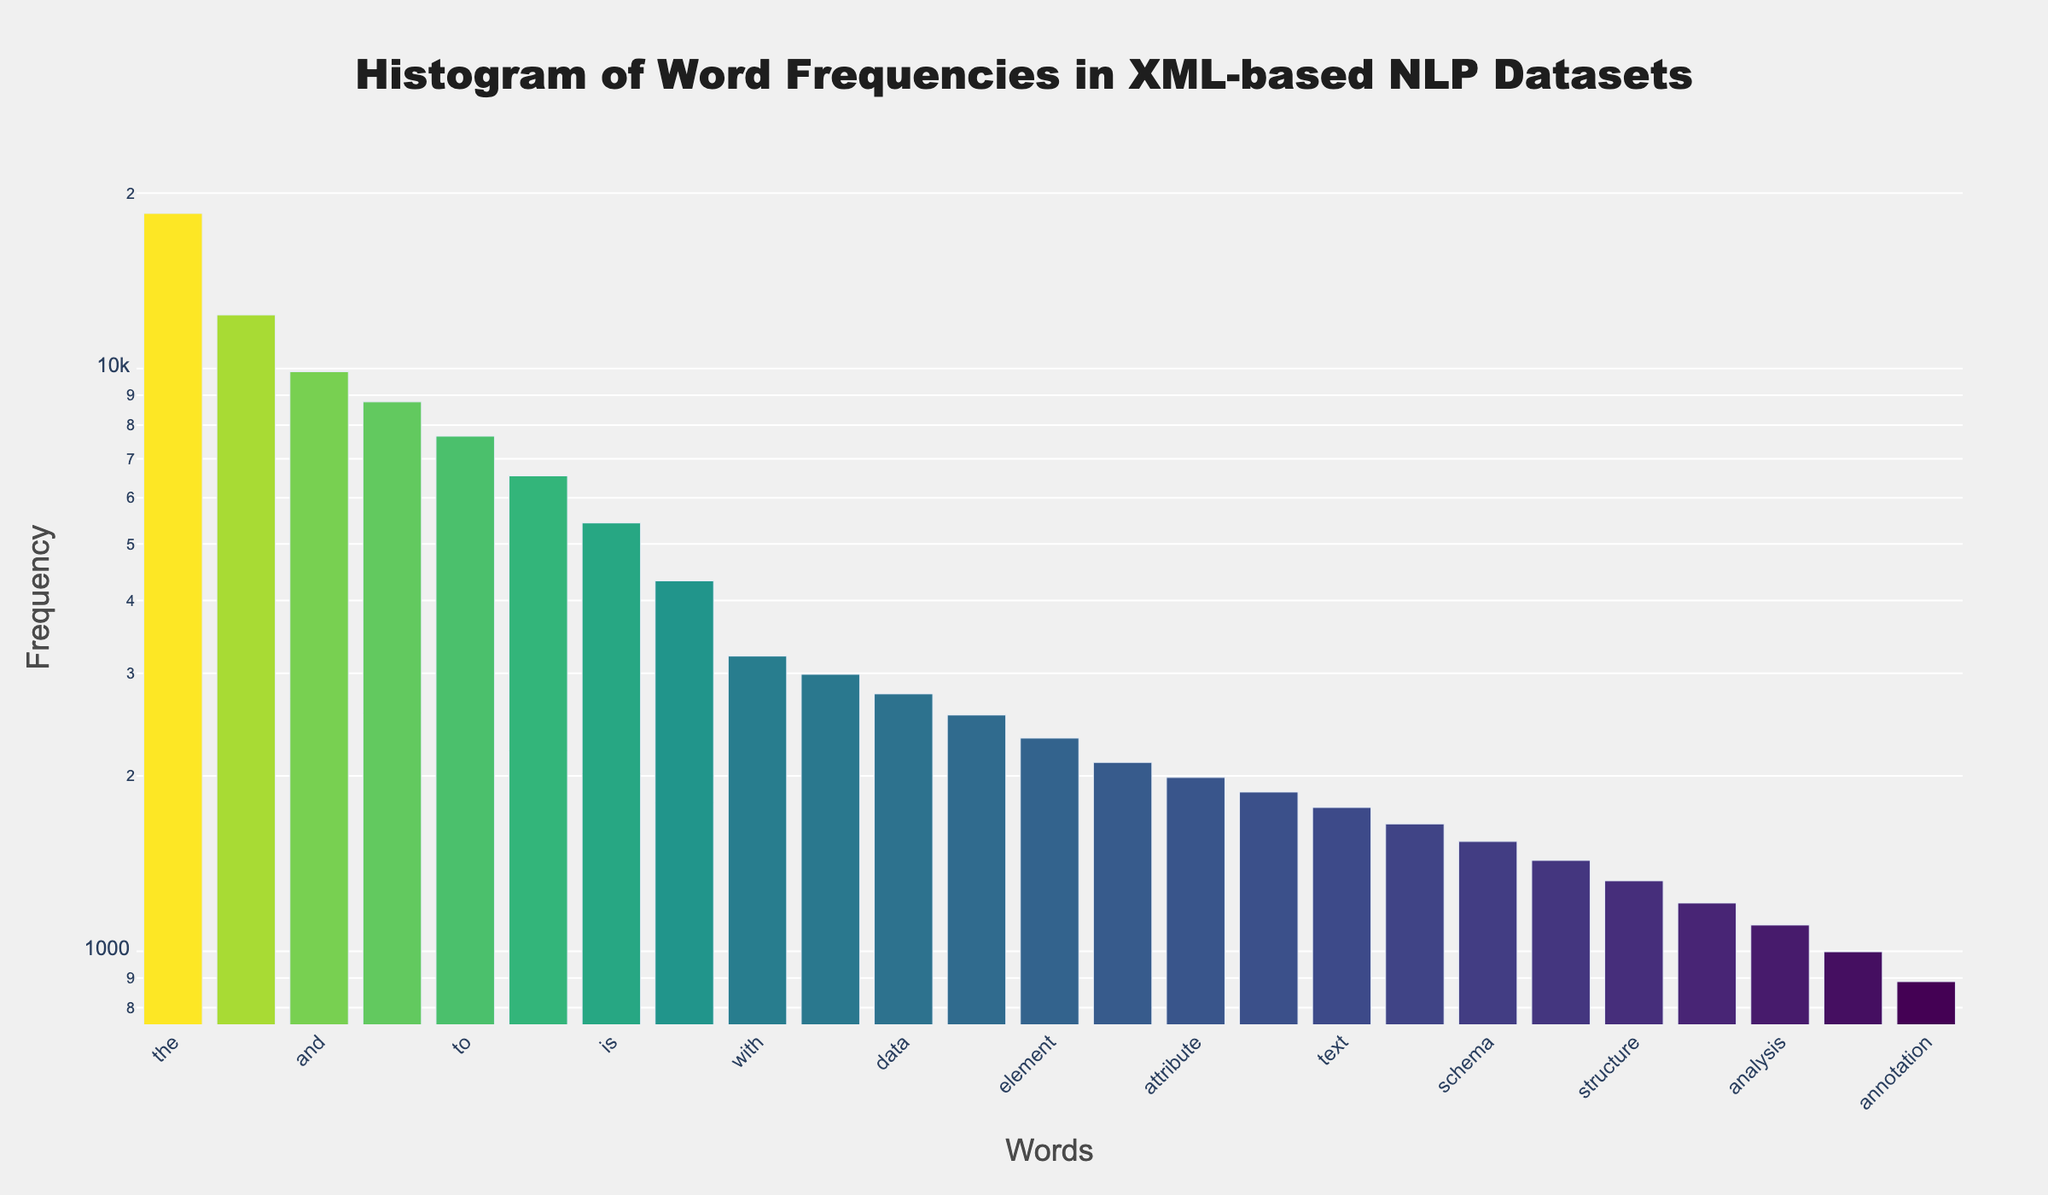What's the title of the histogram? The title is typically located at the top of the figure. In this case, it's clearly written there.
Answer: Histogram of Word Frequencies in XML-based NLP Datasets What are the axis titles? The x-axis title is located below the x-axis, and the y-axis title is located next to the y-axis of the histogram. In this figure, they are labeled as 'Words' and 'Frequency', respectively.
Answer: Words, Frequency What is the color scheme used in the histogram? The histogram uses a color scale to represent the frequency of words, which is mentioned as 'Viridis' in the given code and visually noticeable in the plot.
Answer: Viridis Which word has the highest frequency? By looking at the tallest bar in the histogram and checking its corresponding x-axis label, we find that 'the' has the highest frequency.
Answer: the What is the frequency of the word 'XML'? To find the frequency of 'XML', we locate the corresponding bar for 'XML' on the x-axis and read its height on the y-axis. Alternatively, hover text could give this information directly.
Answer: 2543 How many words have frequencies above 5000? Count the bars whose heights are above the 5000 mark on the y-axis, which would be indicated by the positions of the bars and the logarithmic scaling of the y-axis.
Answer: 7 What is the difference in frequency between 'data' and 'analysis'? First, find the frequencies for 'data' and 'analysis' from the histogram (2765 and 1109, respectively). Then, subtract the smaller frequency from the larger one: 2765 - 1109 = 1656.
Answer: 1656 Which word has the closest frequency to 1000? Look for the bar that is closest to 1000 on the y-axis. The frequency closest to 1000 is for 'corpus', which is 998.
Answer: corpus How does the frequency of 'tag' compare to that of 'attribute'? By identifying both values from the histogram, 'tag' has a frequency of 2109, and 'attribute' has 1987. Comparing these values, 'tag' has a higher frequency than 'attribute'.
Answer: tag has a higher frequency than attribute What's the combined frequency of 'document', 'text', and 'node'? Add their frequencies together: document (1876) + text (1765) + node (1654). Summing these values: 1876 + 1765 + 1654 = 5295.
Answer: 5295 